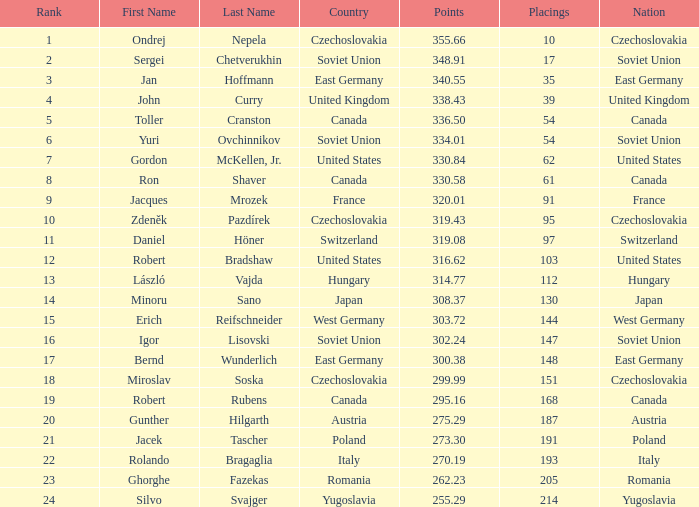Which rank holds a name of john curry and points surpassing 33 None. 